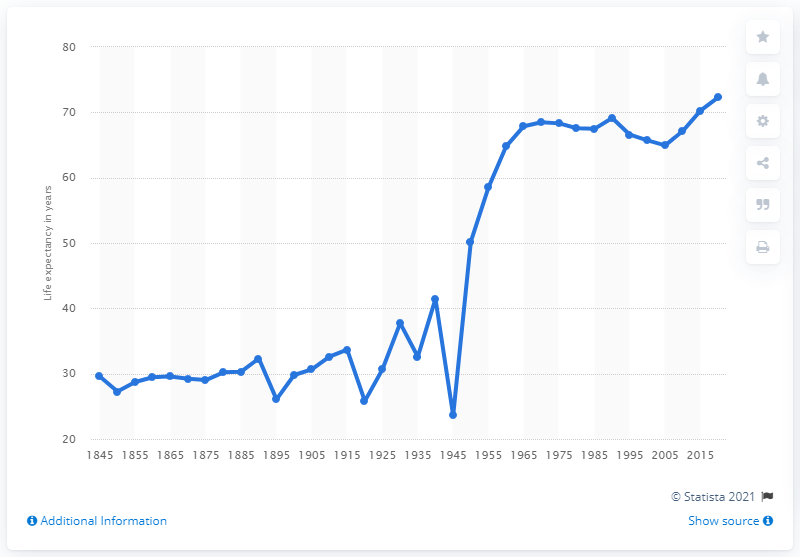Draw attention to some important aspects in this diagram. In the year 1950, Russian life expectancy more than doubled. 